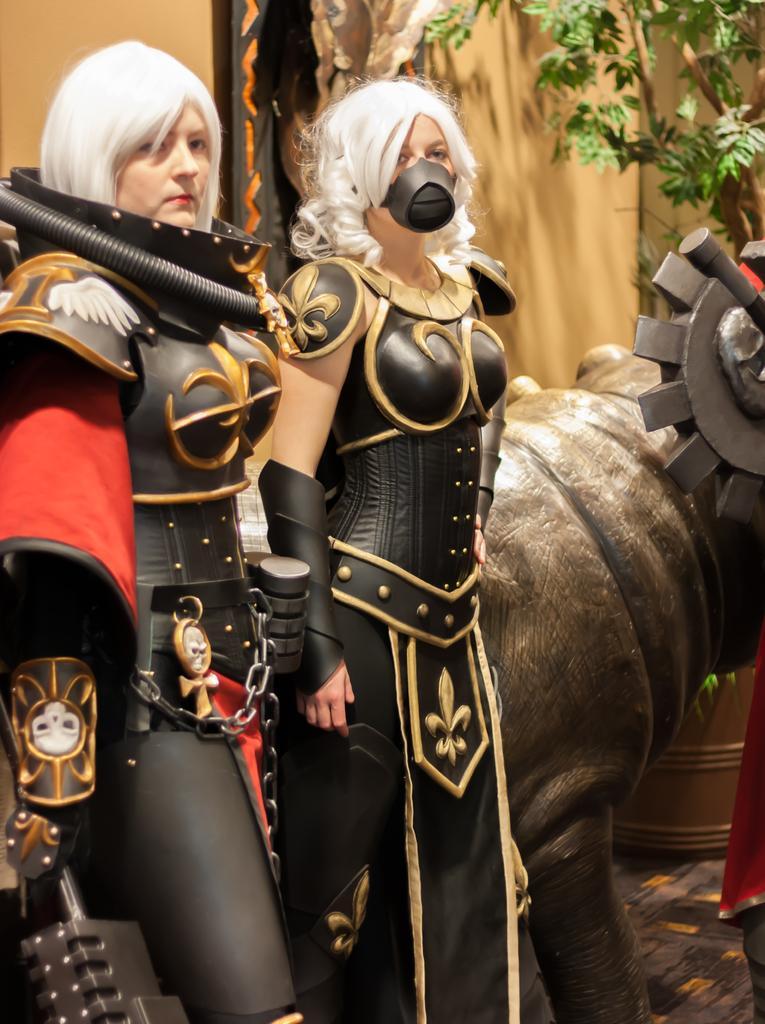Could you give a brief overview of what you see in this image? There are two women's standing on the left side of this image is wearing black color dress and there is a sculpture of an animal on the right side of this image and there is a wall in the background. there are some leaves of a tree at the top right corner of this image. 